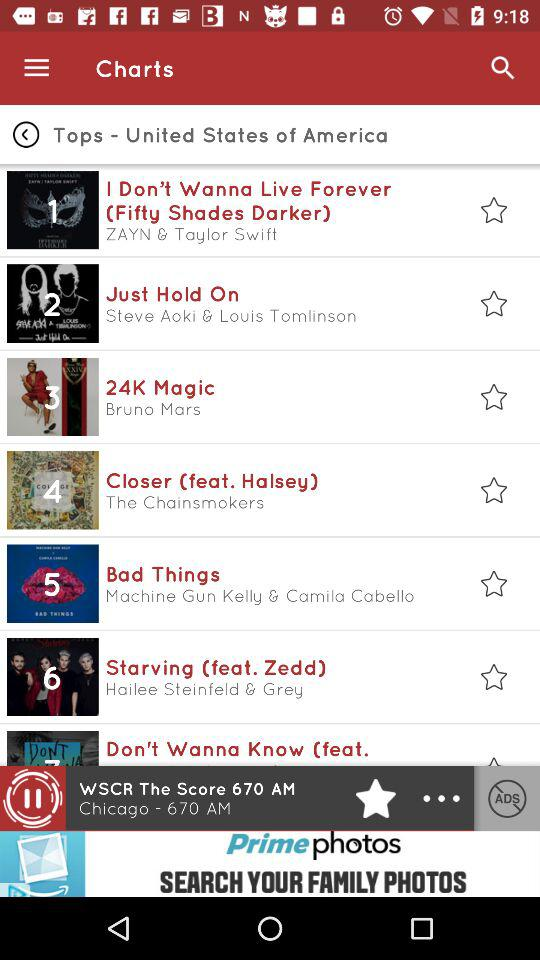What is the available list of songs? The available list of songs is "I Don't Wanna Live Forever (Fifty Shades Darker)", "Just Hold On", "24K Magic", "Closer (feat. Halsey)", "Bad Things", "Starving (feat. Zedd)" and "Don't Wanna Know (feat.". 